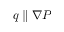<formula> <loc_0><loc_0><loc_500><loc_500>q \| \nabla P</formula> 